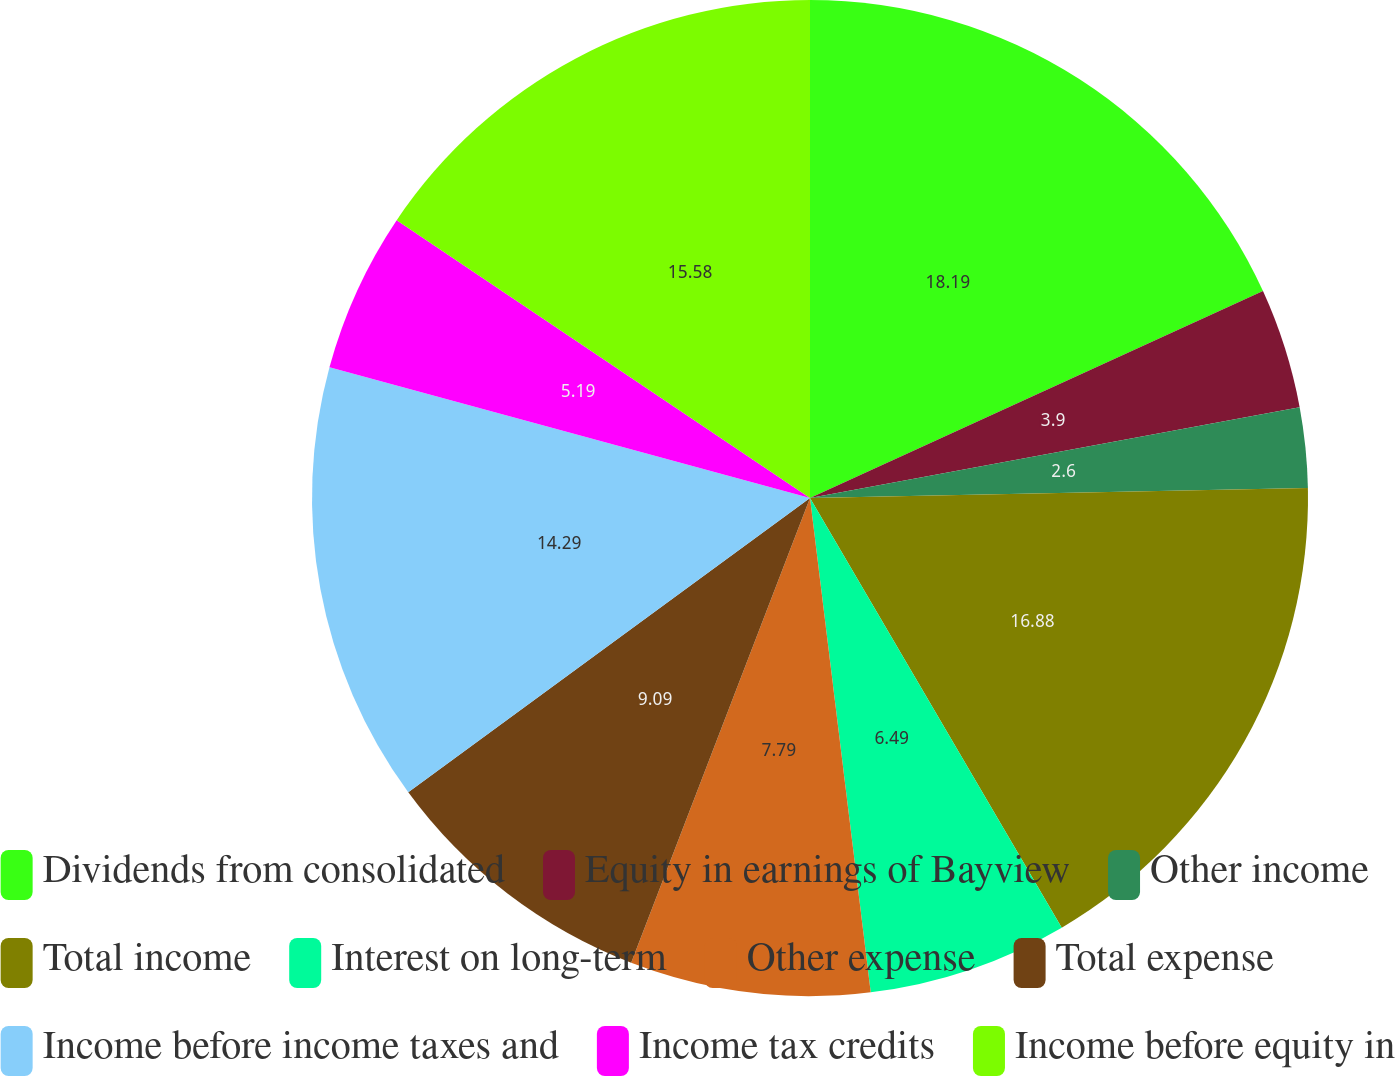Convert chart. <chart><loc_0><loc_0><loc_500><loc_500><pie_chart><fcel>Dividends from consolidated<fcel>Equity in earnings of Bayview<fcel>Other income<fcel>Total income<fcel>Interest on long-term<fcel>Other expense<fcel>Total expense<fcel>Income before income taxes and<fcel>Income tax credits<fcel>Income before equity in<nl><fcel>18.18%<fcel>3.9%<fcel>2.6%<fcel>16.88%<fcel>6.49%<fcel>7.79%<fcel>9.09%<fcel>14.29%<fcel>5.19%<fcel>15.58%<nl></chart> 